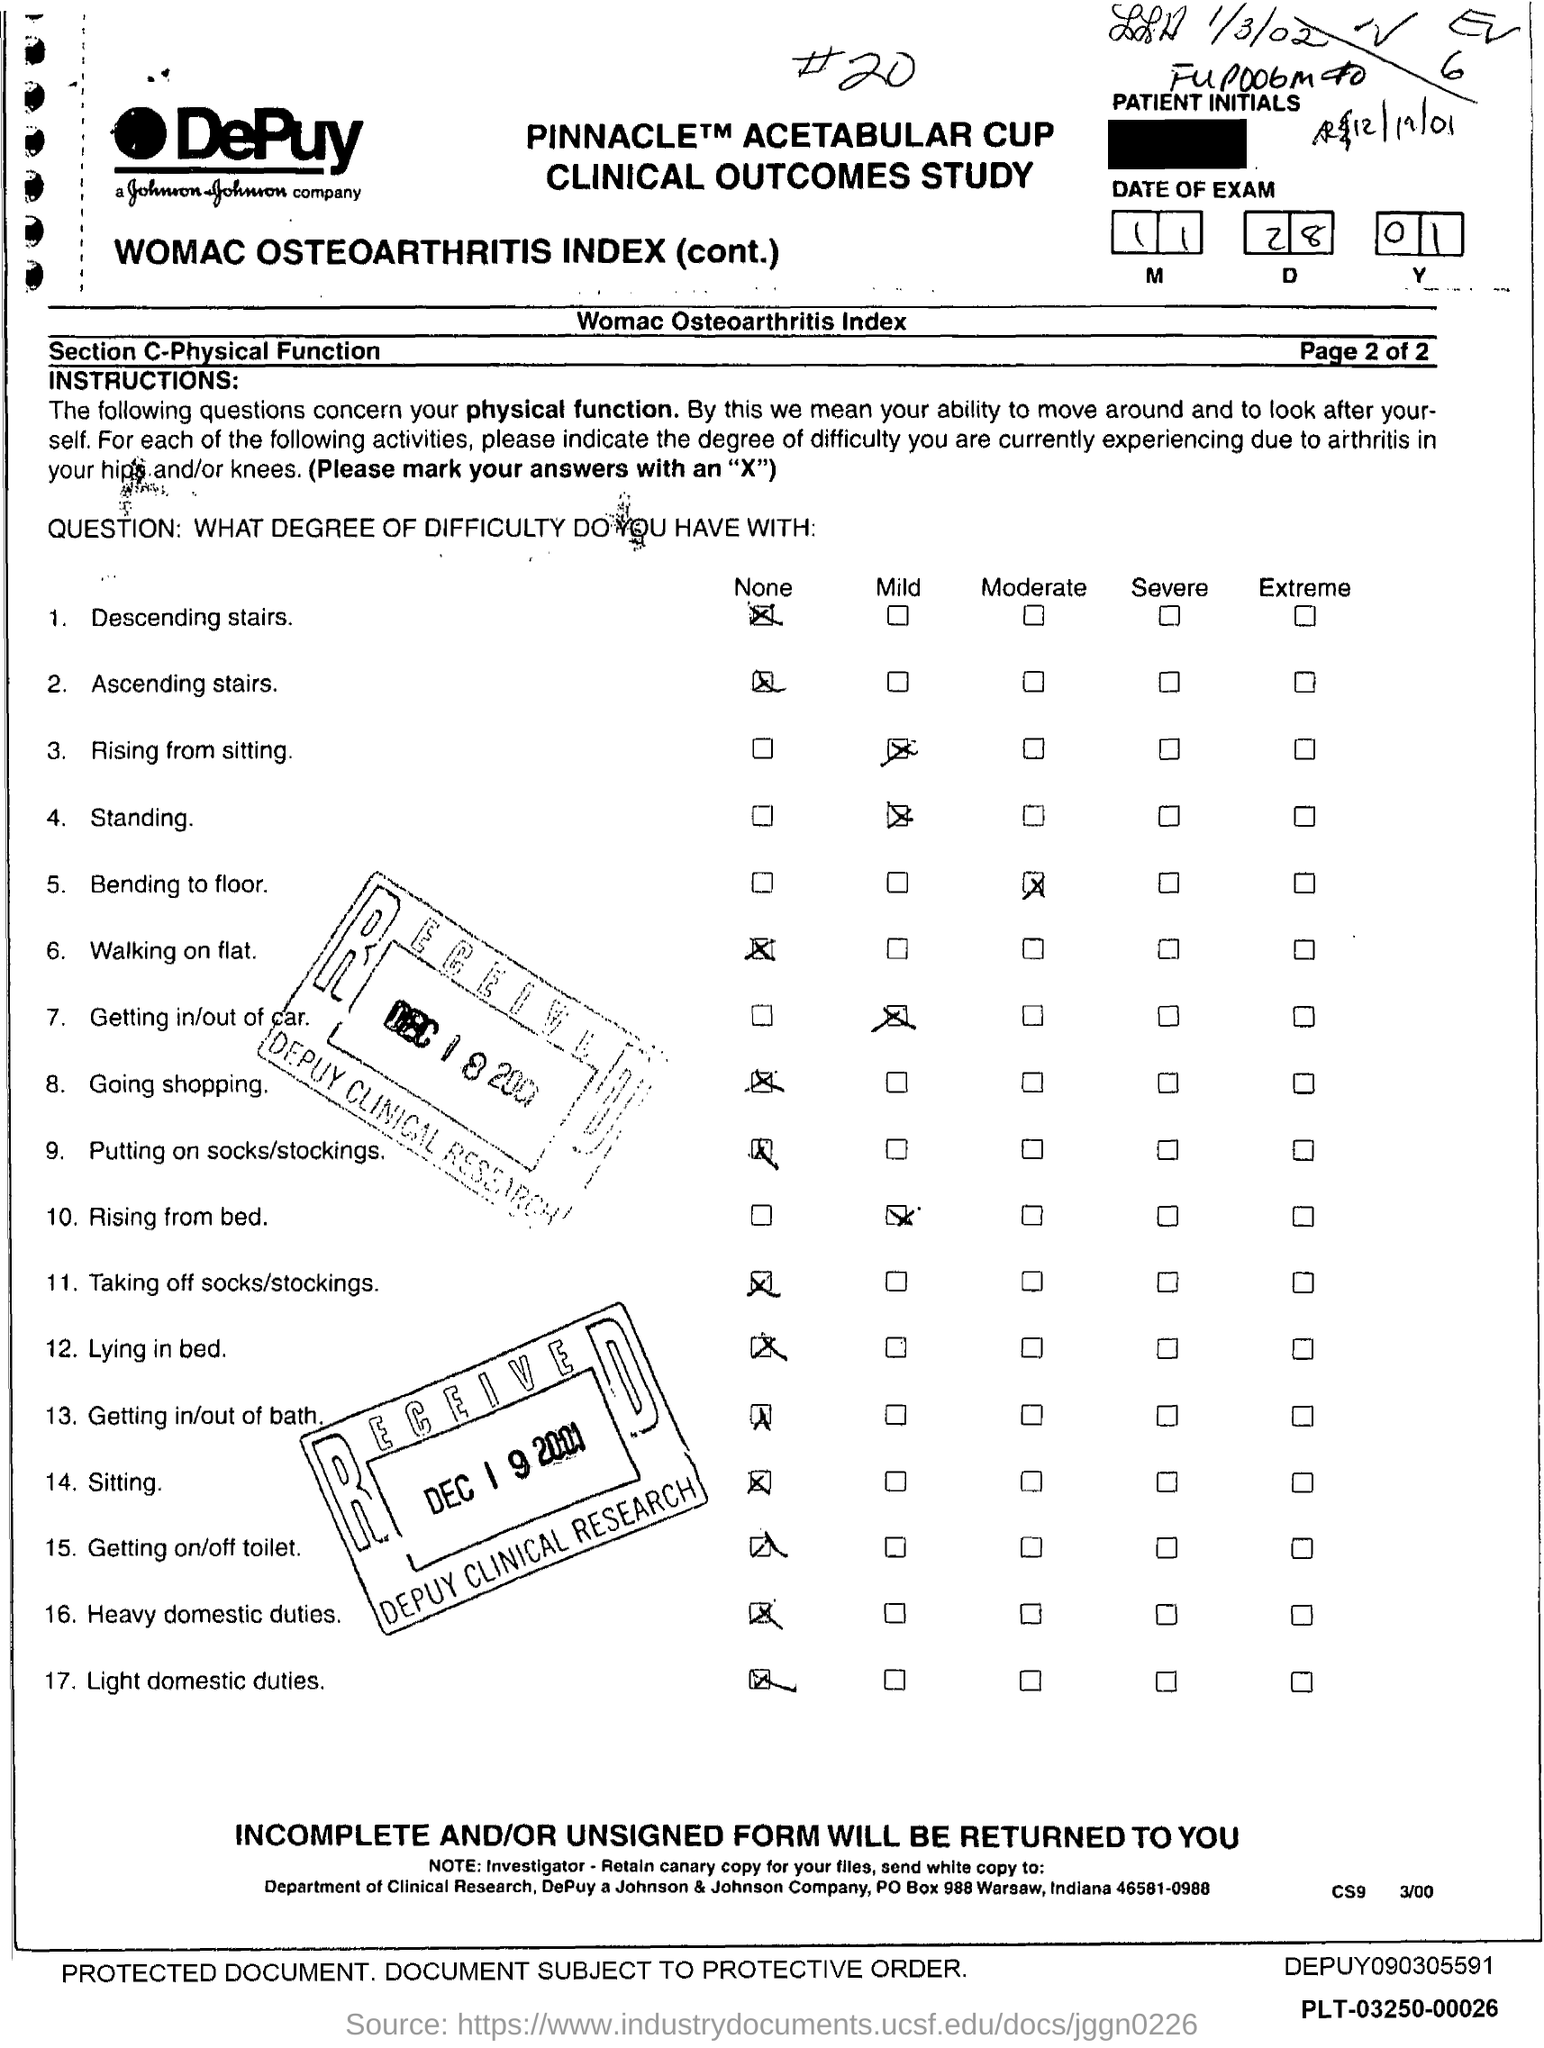Outline some significant characteristics in this image. The date of the exam mentioned in the form is November 28, 2001. 